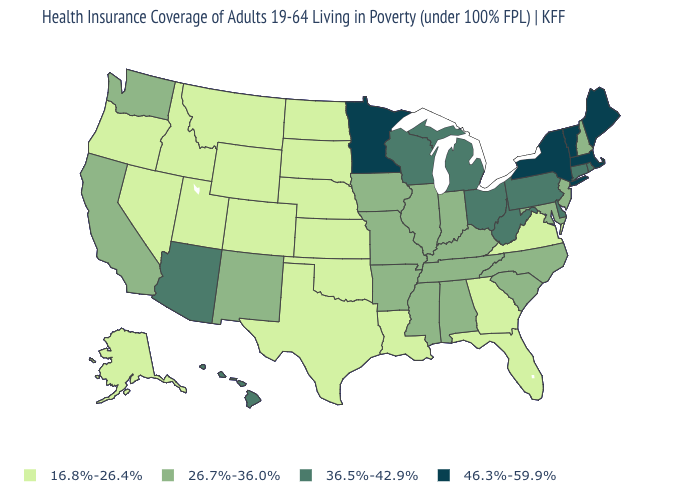Does New Hampshire have the highest value in the Northeast?
Give a very brief answer. No. What is the lowest value in the USA?
Concise answer only. 16.8%-26.4%. Name the states that have a value in the range 26.7%-36.0%?
Concise answer only. Alabama, Arkansas, California, Illinois, Indiana, Iowa, Kentucky, Maryland, Mississippi, Missouri, New Hampshire, New Jersey, New Mexico, North Carolina, South Carolina, Tennessee, Washington. Which states have the lowest value in the MidWest?
Concise answer only. Kansas, Nebraska, North Dakota, South Dakota. Name the states that have a value in the range 26.7%-36.0%?
Write a very short answer. Alabama, Arkansas, California, Illinois, Indiana, Iowa, Kentucky, Maryland, Mississippi, Missouri, New Hampshire, New Jersey, New Mexico, North Carolina, South Carolina, Tennessee, Washington. What is the value of Utah?
Concise answer only. 16.8%-26.4%. What is the highest value in the Northeast ?
Keep it brief. 46.3%-59.9%. What is the lowest value in the USA?
Be succinct. 16.8%-26.4%. What is the value of Illinois?
Write a very short answer. 26.7%-36.0%. What is the value of Nebraska?
Concise answer only. 16.8%-26.4%. Name the states that have a value in the range 36.5%-42.9%?
Short answer required. Arizona, Connecticut, Delaware, Hawaii, Michigan, Ohio, Pennsylvania, Rhode Island, West Virginia, Wisconsin. Which states have the lowest value in the Northeast?
Give a very brief answer. New Hampshire, New Jersey. Among the states that border New Mexico , which have the lowest value?
Write a very short answer. Colorado, Oklahoma, Texas, Utah. 